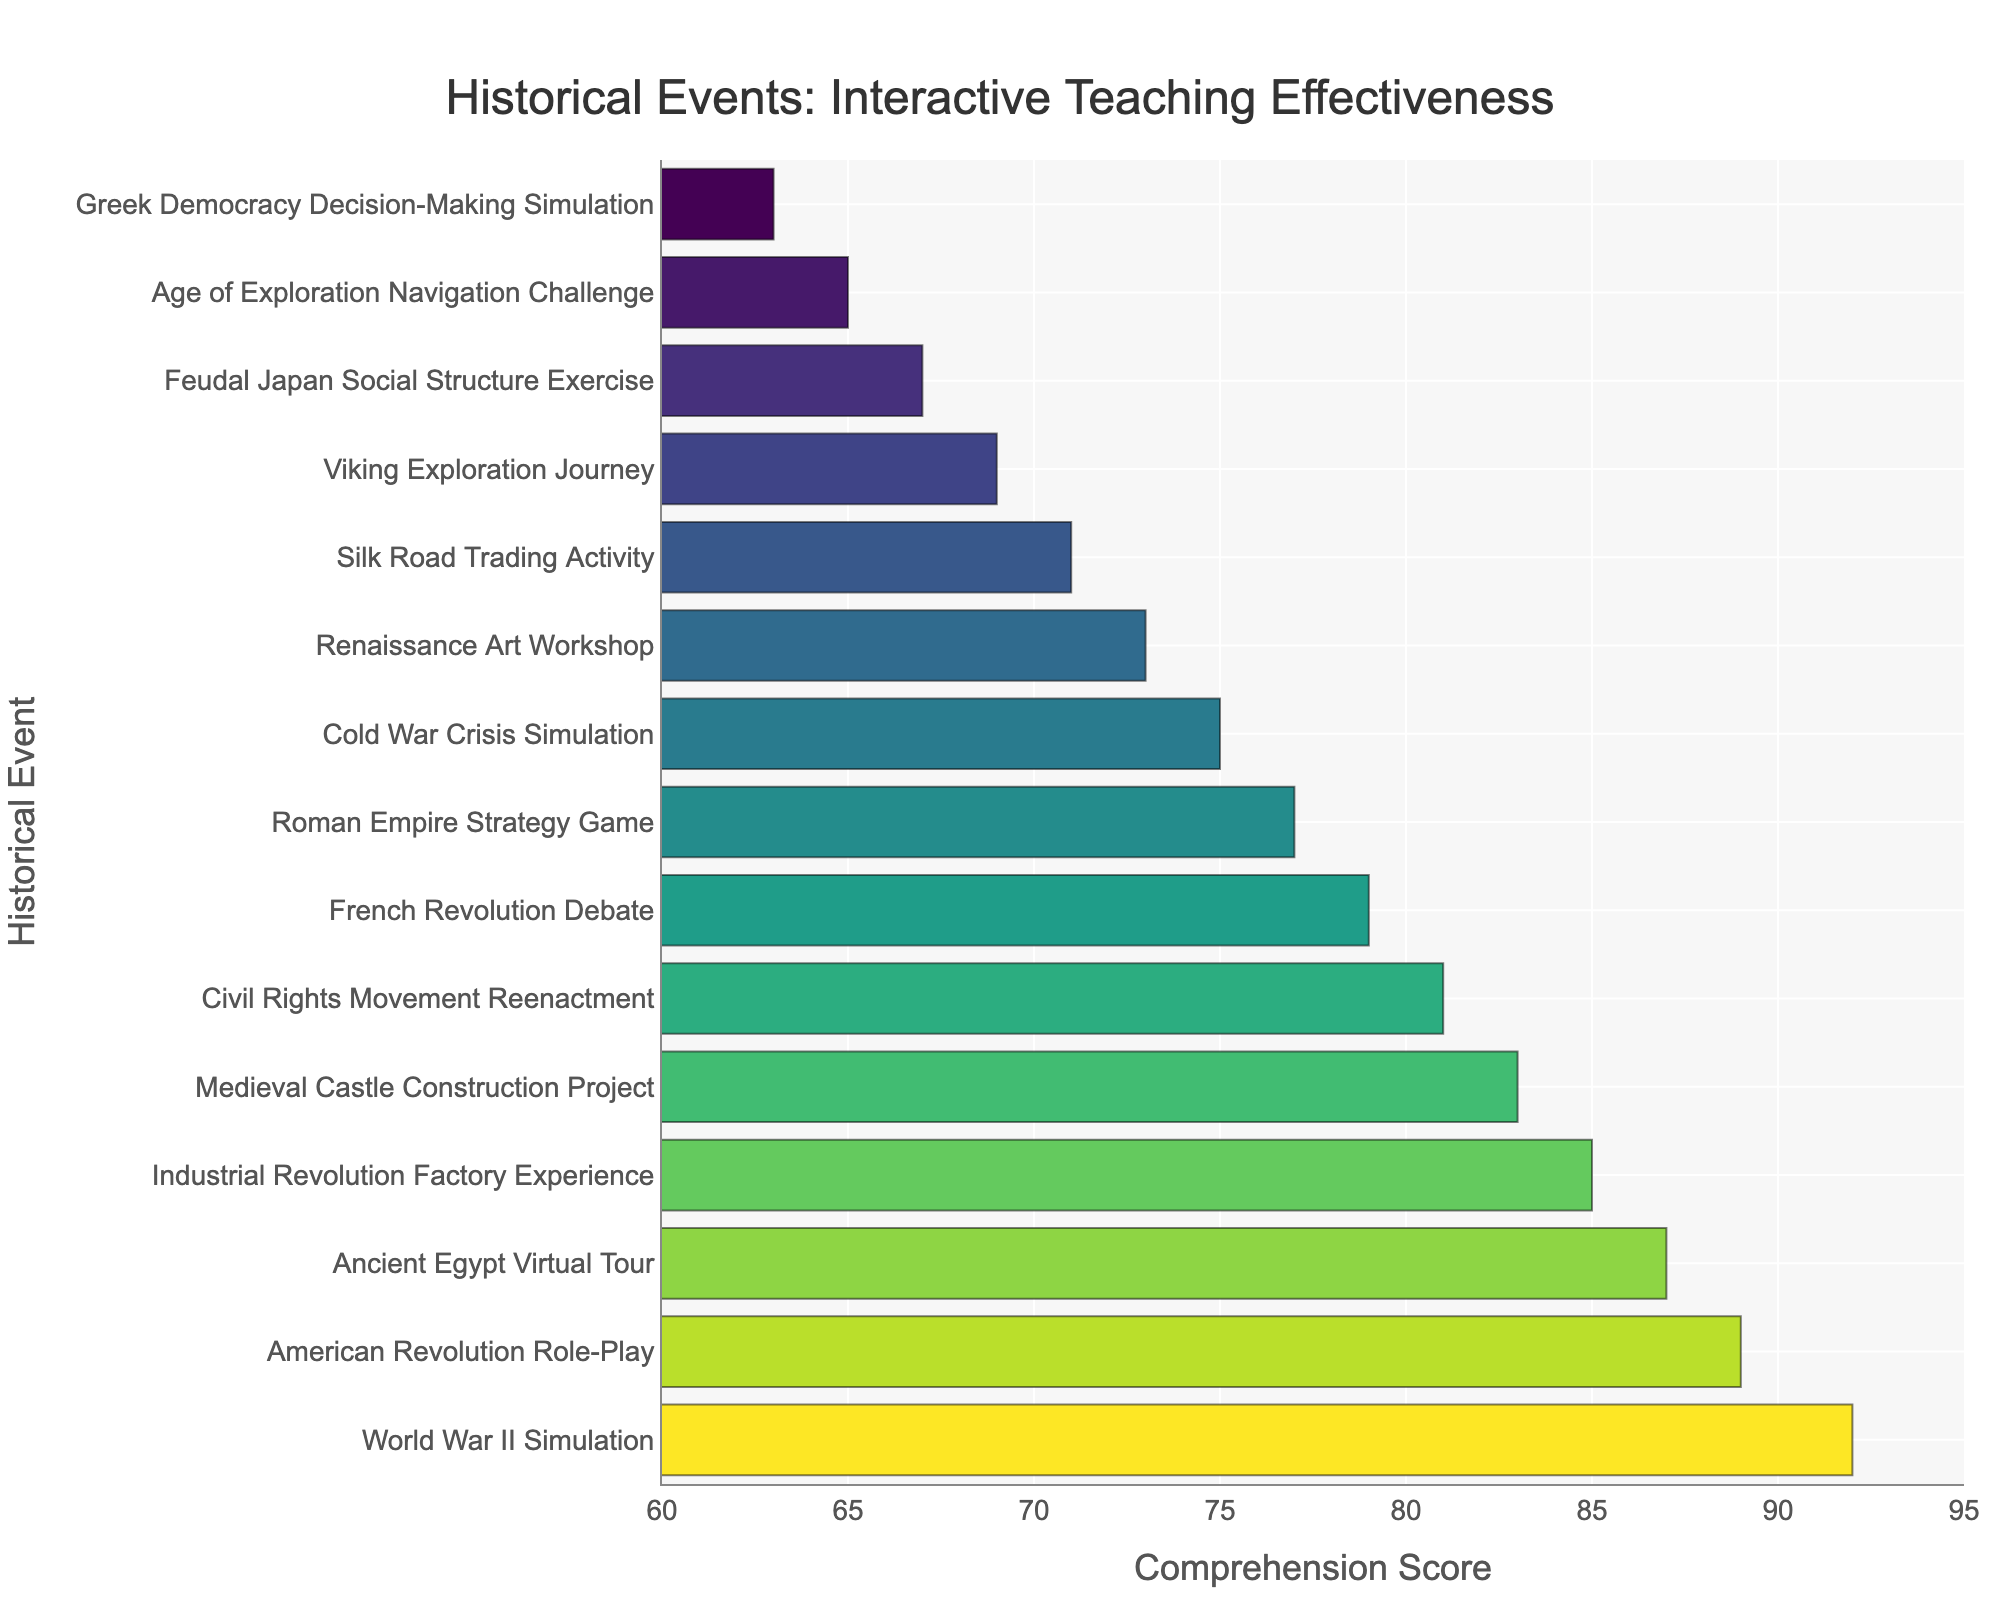What's the highest comprehension score among the historical events? By examining the bar lengths, the highest bar corresponds to "World War II Simulation" with a comprehension score of 92.
Answer: 92 Which event has a higher comprehension score: "French Revolution Debate" or "Silk Road Trading Activity"? The "French Revolution Debate" has a comprehension score of 79 while the "Silk Road Trading Activity" is lower with a score of 71.
Answer: "French Revolution Debate" What is the average comprehension score of the top three events? The top three events and their scores are "World War II Simulation" (92), "American Revolution Role-Play" (89), and "Ancient Egypt Virtual Tour" (87). The average is calculated as (92 + 89 + 87)/3 = 268/3 = 89.33.
Answer: 89.33 How much higher is the comprehension score of "Industrial Revolution Factory Experience" compared to "Renaissance Art Workshop"? The "Industrial Revolution Factory Experience" has a comprehension score of 85, while "Renaissance Art Workshop" has 73. The difference is 85 - 73 = 12.
Answer: 12 List the events with a comprehension score less than 70. The events with scores less than 70 are "Viking Exploration Journey" (69), "Feudal Japan Social Structure Exercise" (67), "Age of Exploration Navigation Challenge" (65), and "Greek Democracy Decision-Making Simulation" (63).
Answer: "Viking Exploration Journey", "Feudal Japan Social Structure Exercise", "Age of Exploration Navigation Challenge", "Greek Democracy Decision-Making Simulation" Which event has the lowest comprehension score and what is that score? The event with the lowest comprehension score is "Greek Democracy Decision-Making Simulation" with a score of 63.
Answer: "Greek Democracy Decision-Making Simulation", 63 Are there more events with a comprehension score above 80 or below 70? Events above 80 are "World War II Simulation" (92), "American Revolution Role-Play" (89), "Ancient Egypt Virtual Tour" (87), "Industrial Revolution Factory Experience" (85), "Medieval Castle Construction Project" (83), and "Civil Rights Movement Reenactment" (81), totaling 6 events. Events below 70 are "Viking Exploration Journey" (69), "Feudal Japan Social Structure Exercise" (67), "Age of Exploration Navigation Challenge" (65), and "Greek Democracy Decision-Making Simulation" (63), totaling 4 events. So, more events have scores above 80.
Answer: Above 80 What is the median comprehension score of all the events? Arrange the scores in ascending order: 63, 65, 67, 69, 71, 73, 75, 77, 79, 81, 83, 85, 87, 89, 92. With 15 scores, the median is the 8th score, which is 77.
Answer: 77 Which event ranks second in terms of comprehension score? The event with the second-highest comprehension score is "American Revolution Role-Play" with a score of 89.
Answer: "American Revolution Role-Play" What is the sum of comprehension scores for the first five events as ranked by their scores? The scores for the first five events are "World War II Simulation" (92), "American Revolution Role-Play" (89), "Ancient Egypt Virtual Tour" (87), "Industrial Revolution Factory Experience" (85), and "Medieval Castle Construction Project" (83). Summing these gives 92 + 89 + 87 + 85 + 83 = 436.
Answer: 436 